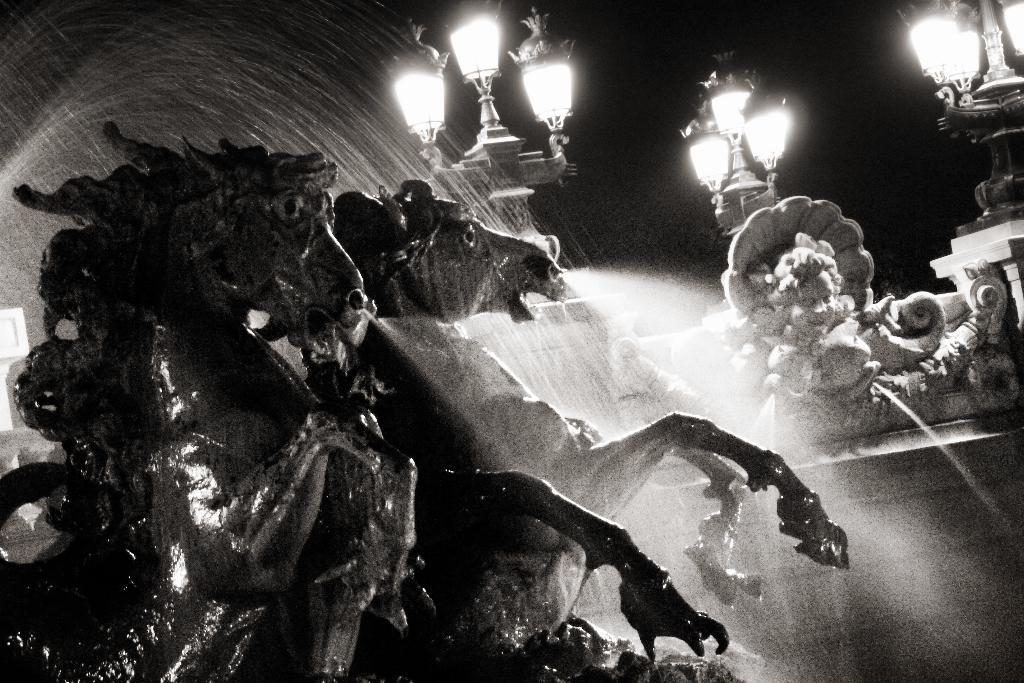What type of art is present in the image? There are sculptures in the image. What is the setting of the sculptures? There is a wall in the image, which may be the backdrop for the sculptures. What is illuminating the sculptures in the image? Lamps are visible behind the sculptures, providing light. What natural element is present in the image? There is water in the image. How would you describe the overall lighting in the image? The background of the image is dark, which may create a contrast with the lit sculptures. What type of mark can be seen on the sculptures in the image? There is no mention of any marks on the sculptures in the image. --- Facts: 1. There is a person sitting on a chair in the image. 2. The person is holding a book. 3. There is a table next to the chair. 4. A lamp is on the table. 5. The background of the image is a bookshelf. Absurd Topics: parrot, sand, bicycle Conversation: What is the person in the image doing? The person is sitting on a chair in the image. What is the person holding in the image? The person is holding a book. What is on the table next to the chair? A lamp is on the table. What is the background of the image? The background of the image is a bookshelf. Reasoning: Let's think step by step in order to produce the conversation. We start by identifying the main subject in the image, which is the person sitting on a chair. Then, we expand the conversation to include other elements that are also visible, such as the book, table, lamp, and bookshelf background. Each question is designed to elicit a specific detail about the image that is known from the provided facts. Absurd Question/Answer: What type of parrot can be seen sitting on the bicycle in the image? There is no parrot or bicycle present in the image. 